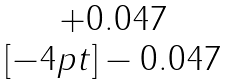<formula> <loc_0><loc_0><loc_500><loc_500>\begin{matrix} + 0 . 0 4 7 \\ [ - 4 p t ] - 0 . 0 4 7 \end{matrix}</formula> 